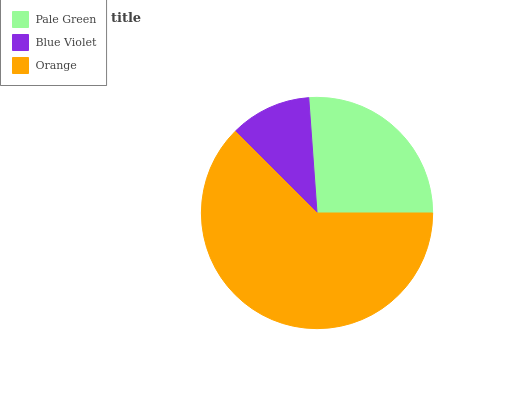Is Blue Violet the minimum?
Answer yes or no. Yes. Is Orange the maximum?
Answer yes or no. Yes. Is Orange the minimum?
Answer yes or no. No. Is Blue Violet the maximum?
Answer yes or no. No. Is Orange greater than Blue Violet?
Answer yes or no. Yes. Is Blue Violet less than Orange?
Answer yes or no. Yes. Is Blue Violet greater than Orange?
Answer yes or no. No. Is Orange less than Blue Violet?
Answer yes or no. No. Is Pale Green the high median?
Answer yes or no. Yes. Is Pale Green the low median?
Answer yes or no. Yes. Is Orange the high median?
Answer yes or no. No. Is Orange the low median?
Answer yes or no. No. 